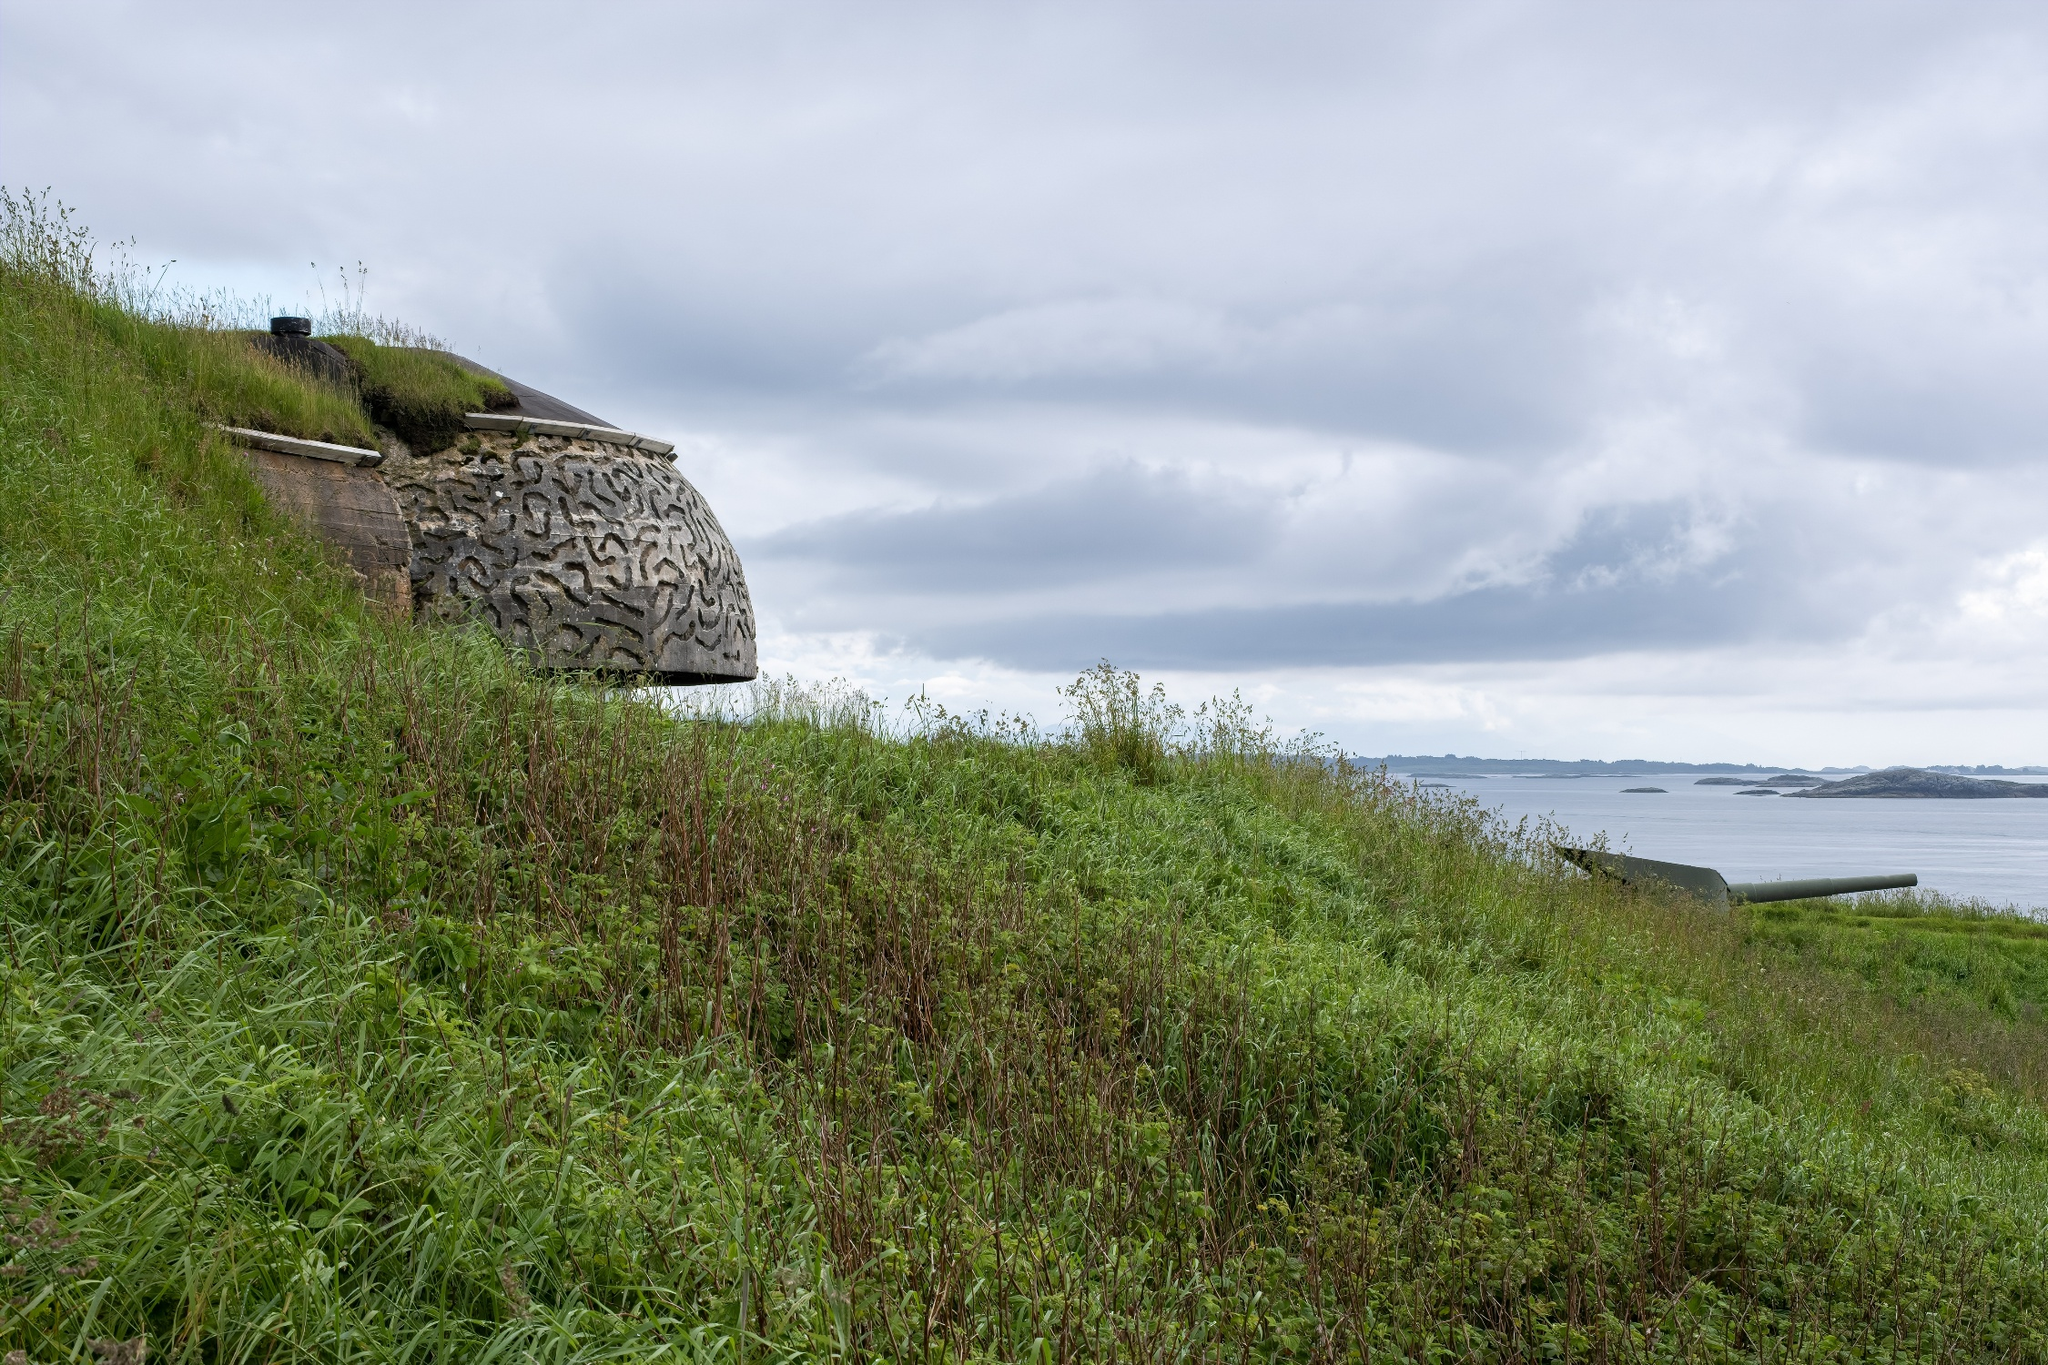What sounds would you hear if you were standing at this place? Standing in this serene location, you would likely hear the gentle rustling of the grass as a breeze flows through the hillside. The occasional chirping of birds from nearby shrubs adds a charming melody to the soundscape. The distant, rhythmic sound of waves hitting the shore from the expansive ocean would provide a calming backdrop. Periodically, the wind might whistle through the small window of the stone bunker, adding an eerie yet soothing note. Together, these sounds create a peaceful and reflective auditory experience, harmonious with the tranquil visual setting. 